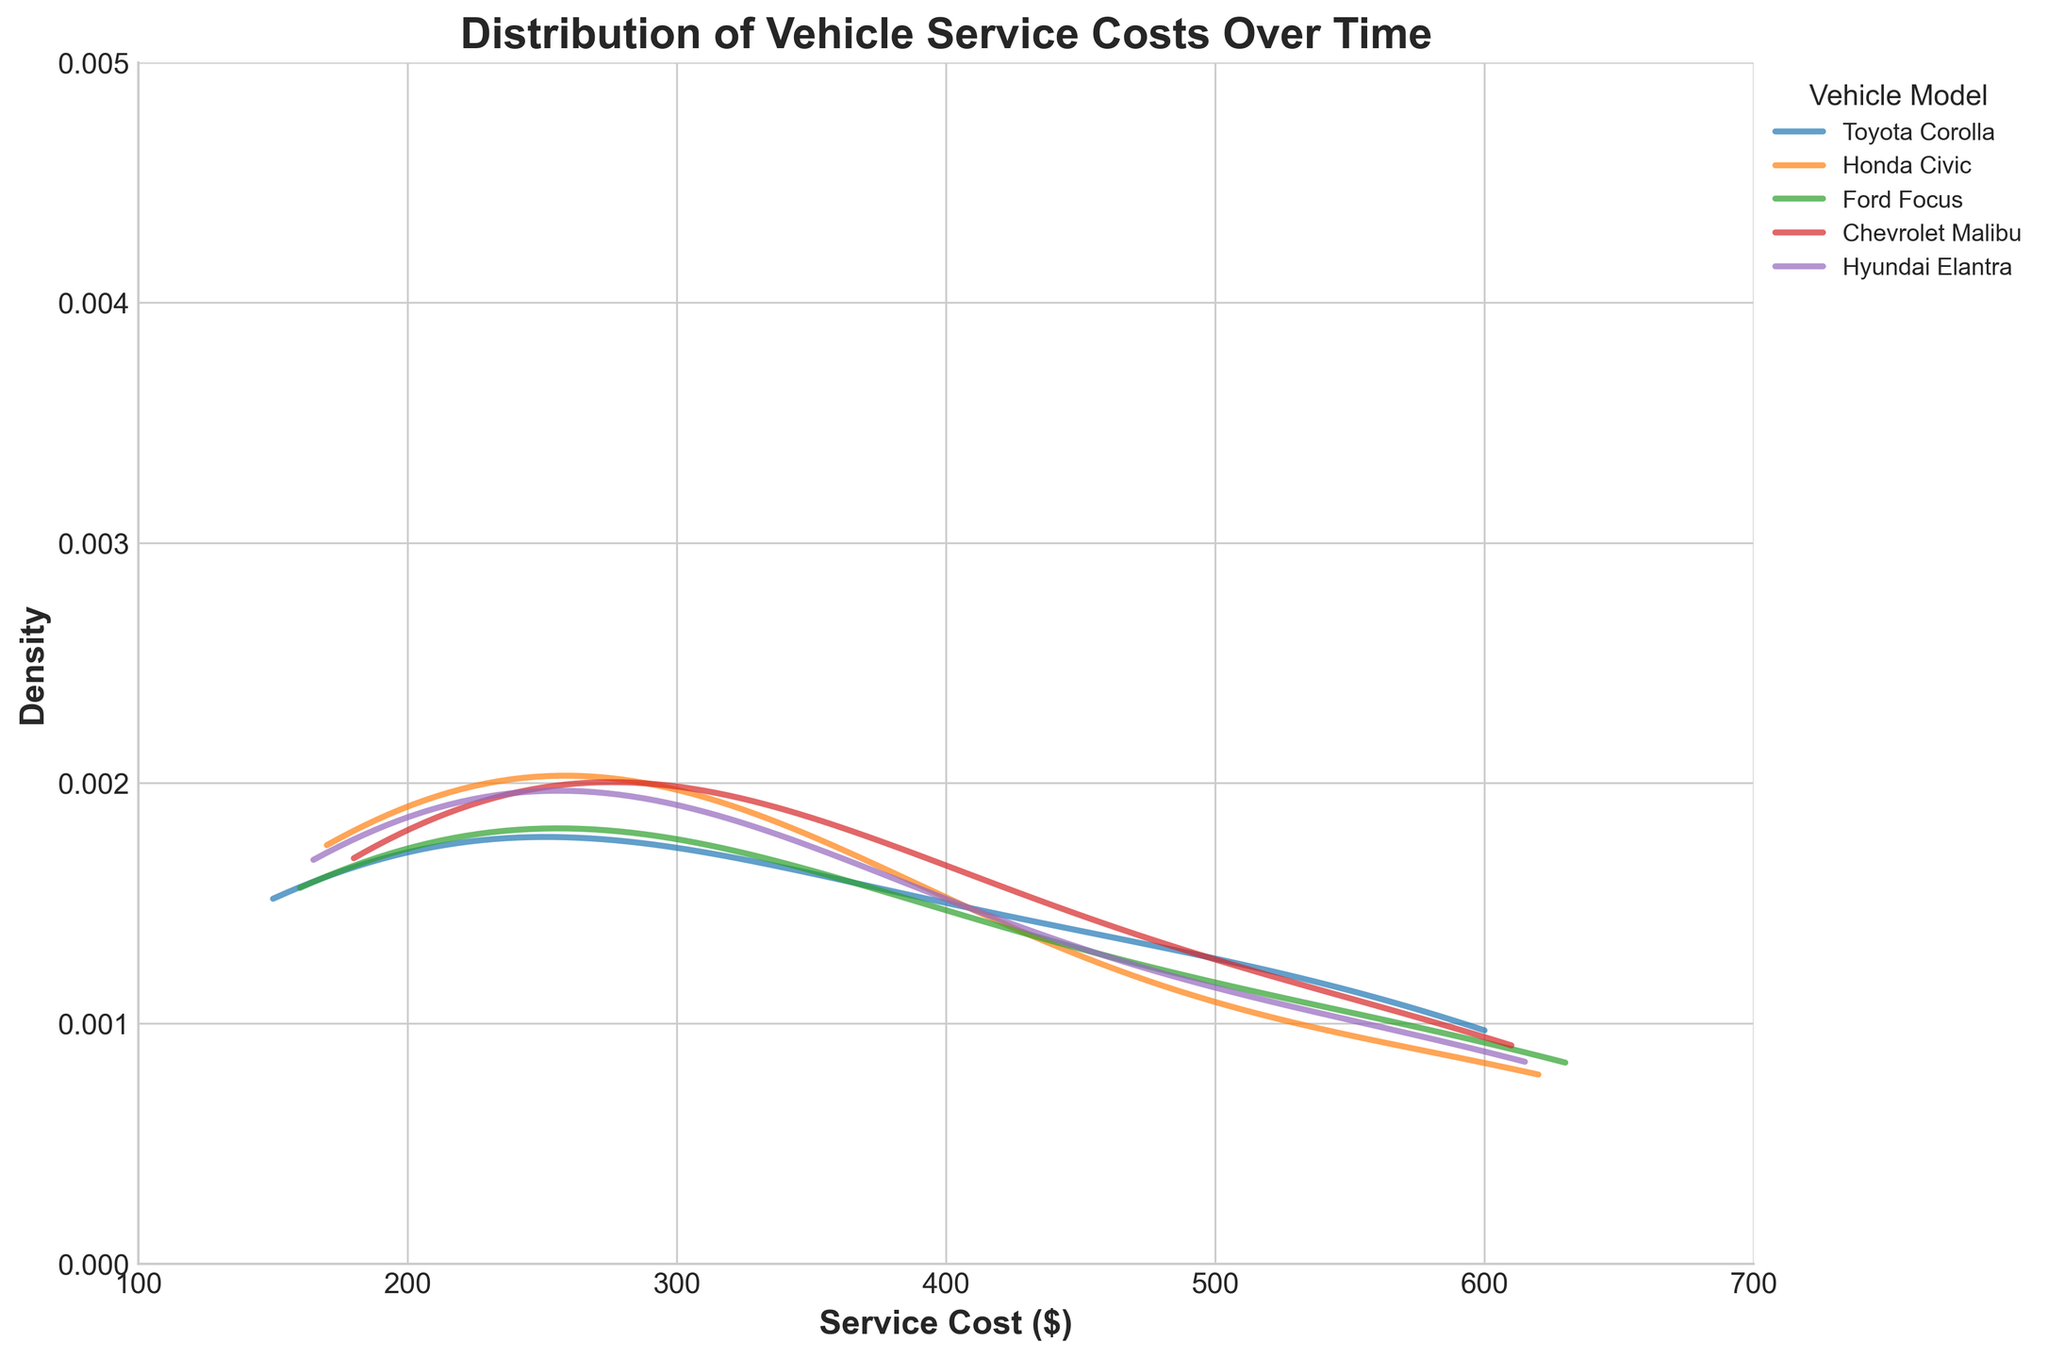What is the main title of the plot? The main title is typically placed at the top center of the plot and is meant to give an overview of what the plot is about. The title here reads 'Distribution of Vehicle Service Costs Over Time'.
Answer: Distribution of Vehicle Service Costs Over Time What is the range of the x-axis in the plot? The x-axis represents the Service Cost and ranges from $100 to $700, which can be determined by looking at the labels and tick marks along the axis.
Answer: $100 to $700 Which vehicle model shows the highest density for service costs? To identify the vehicle model with the highest density, we look at the peaks (highest points) of the density curves. In the plot, the Ford Focus curve has the highest peak.
Answer: Ford Focus How does the service cost distribution of the Toyota Corolla compare to the Honda Civic? By comparing the density curves, we can see that both vehicles show density peaks around similar cost ranges, but the Honda Civic generally has slightly lower peaks compared to the Toyota Corolla, indicating more dispersed costs.
Answer: Toyota Corolla has higher peaks Which vehicle model shows the most variation in service costs? The most variation in service costs can be observed from the width of the density curve—the wider the distribution, the more variation. The Chevrolet Malibu's curve appears wider compared to other models.
Answer: Chevrolet Malibu What does the y-axis represent in this plot? In this density plot, the y-axis represents the density, showing how frequent specific service costs are within the dataset. Higher densities indicate more frequent occurrences of those service costs.
Answer: Density Do any vehicle models have overlapping service cost ranges? To determine overlap, we observe where the density curves of different vehicle models intersect or run parallel. The service cost ranges for the Toyota Corolla, Honda Civic, and Ford Focus overlap significantly.
Answer: Yes Which vehicle model has the highest peak in service cost density? The density peak is the highest point on the density curve. The Ford Focus shows the highest peak on its density curve, indicating that its service cost distribution has a distinct mode.
Answer: Ford Focus At what service cost range do all vehicle models show some density? We can determine the common service cost range by observing where all the density curves maintain some height simultaneously. All vehicle models show some density in the $150 to $450 range.
Answer: $150 to $450 What is the shape of the density curve for the Hyundai Elantra compared to others? By looking at the density curves, we can compare their shapes. The Hyundai Elantra has a more uniform and flatter density curve, indicating a more spread-out distribution of service costs without sharp peaks.
Answer: More uniform and flatter 